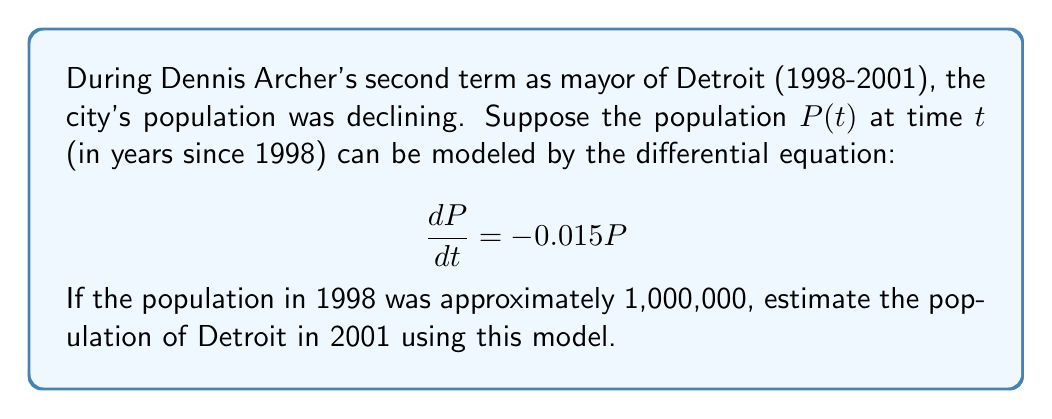Can you answer this question? To solve this problem, we need to use the following steps:

1) The given differential equation is a first-order linear equation of the form:

   $$\frac{dP}{dt} = kP$$

   where $k = -0.015$ in this case.

2) The solution to this type of equation is an exponential function:

   $$P(t) = P_0e^{kt}$$

   where $P_0$ is the initial population.

3) We're given that $P_0 = 1,000,000$ in 1998.

4) We need to find $P(3)$, as 2001 is 3 years after 1998.

5) Substituting these values into our solution:

   $$P(3) = 1,000,000e^{(-0.015)(3)}$$

6) Simplifying:

   $$P(3) = 1,000,000e^{-0.045}$$

7) Using a calculator or computer to evaluate this expression:

   $$P(3) \approx 955,997$$

Therefore, according to this model, the population of Detroit in 2001 would be approximately 955,997.
Answer: $P(3) \approx 955,997$ 